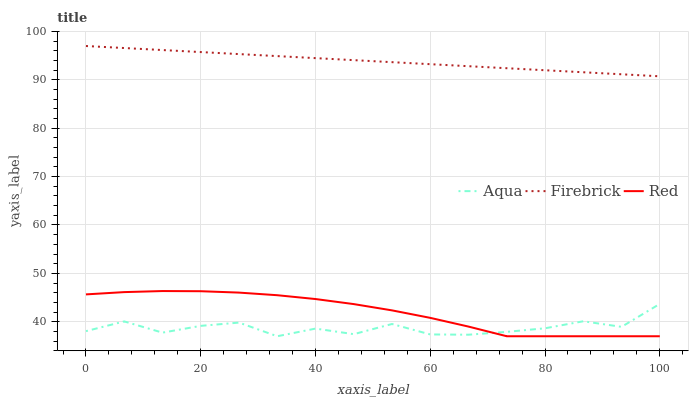Does Aqua have the minimum area under the curve?
Answer yes or no. Yes. Does Firebrick have the maximum area under the curve?
Answer yes or no. Yes. Does Red have the minimum area under the curve?
Answer yes or no. No. Does Red have the maximum area under the curve?
Answer yes or no. No. Is Firebrick the smoothest?
Answer yes or no. Yes. Is Aqua the roughest?
Answer yes or no. Yes. Is Red the smoothest?
Answer yes or no. No. Is Red the roughest?
Answer yes or no. No. Does Aqua have the lowest value?
Answer yes or no. Yes. Does Firebrick have the highest value?
Answer yes or no. Yes. Does Red have the highest value?
Answer yes or no. No. Is Aqua less than Firebrick?
Answer yes or no. Yes. Is Firebrick greater than Aqua?
Answer yes or no. Yes. Does Red intersect Aqua?
Answer yes or no. Yes. Is Red less than Aqua?
Answer yes or no. No. Is Red greater than Aqua?
Answer yes or no. No. Does Aqua intersect Firebrick?
Answer yes or no. No. 